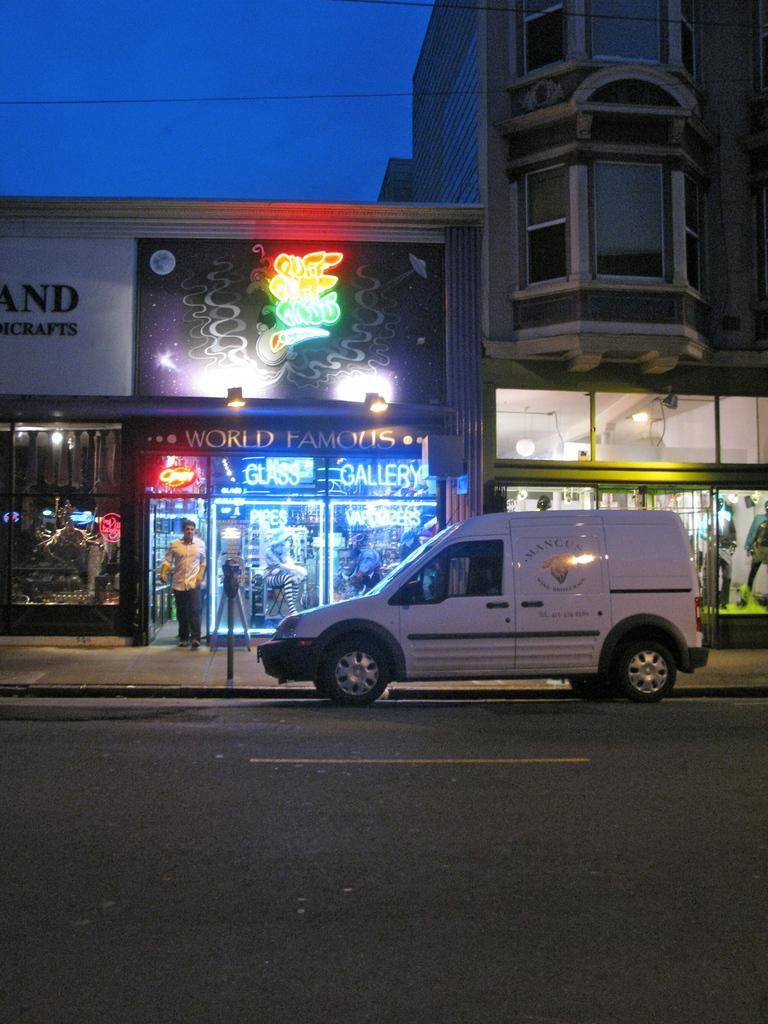Can you describe this image briefly? In the image we can see the building and the windows of the building. Here we can see LED poster and text. We can even see the vehicle and there is a person standing, wearing clothes. Here we can see electric wire and the sky. 